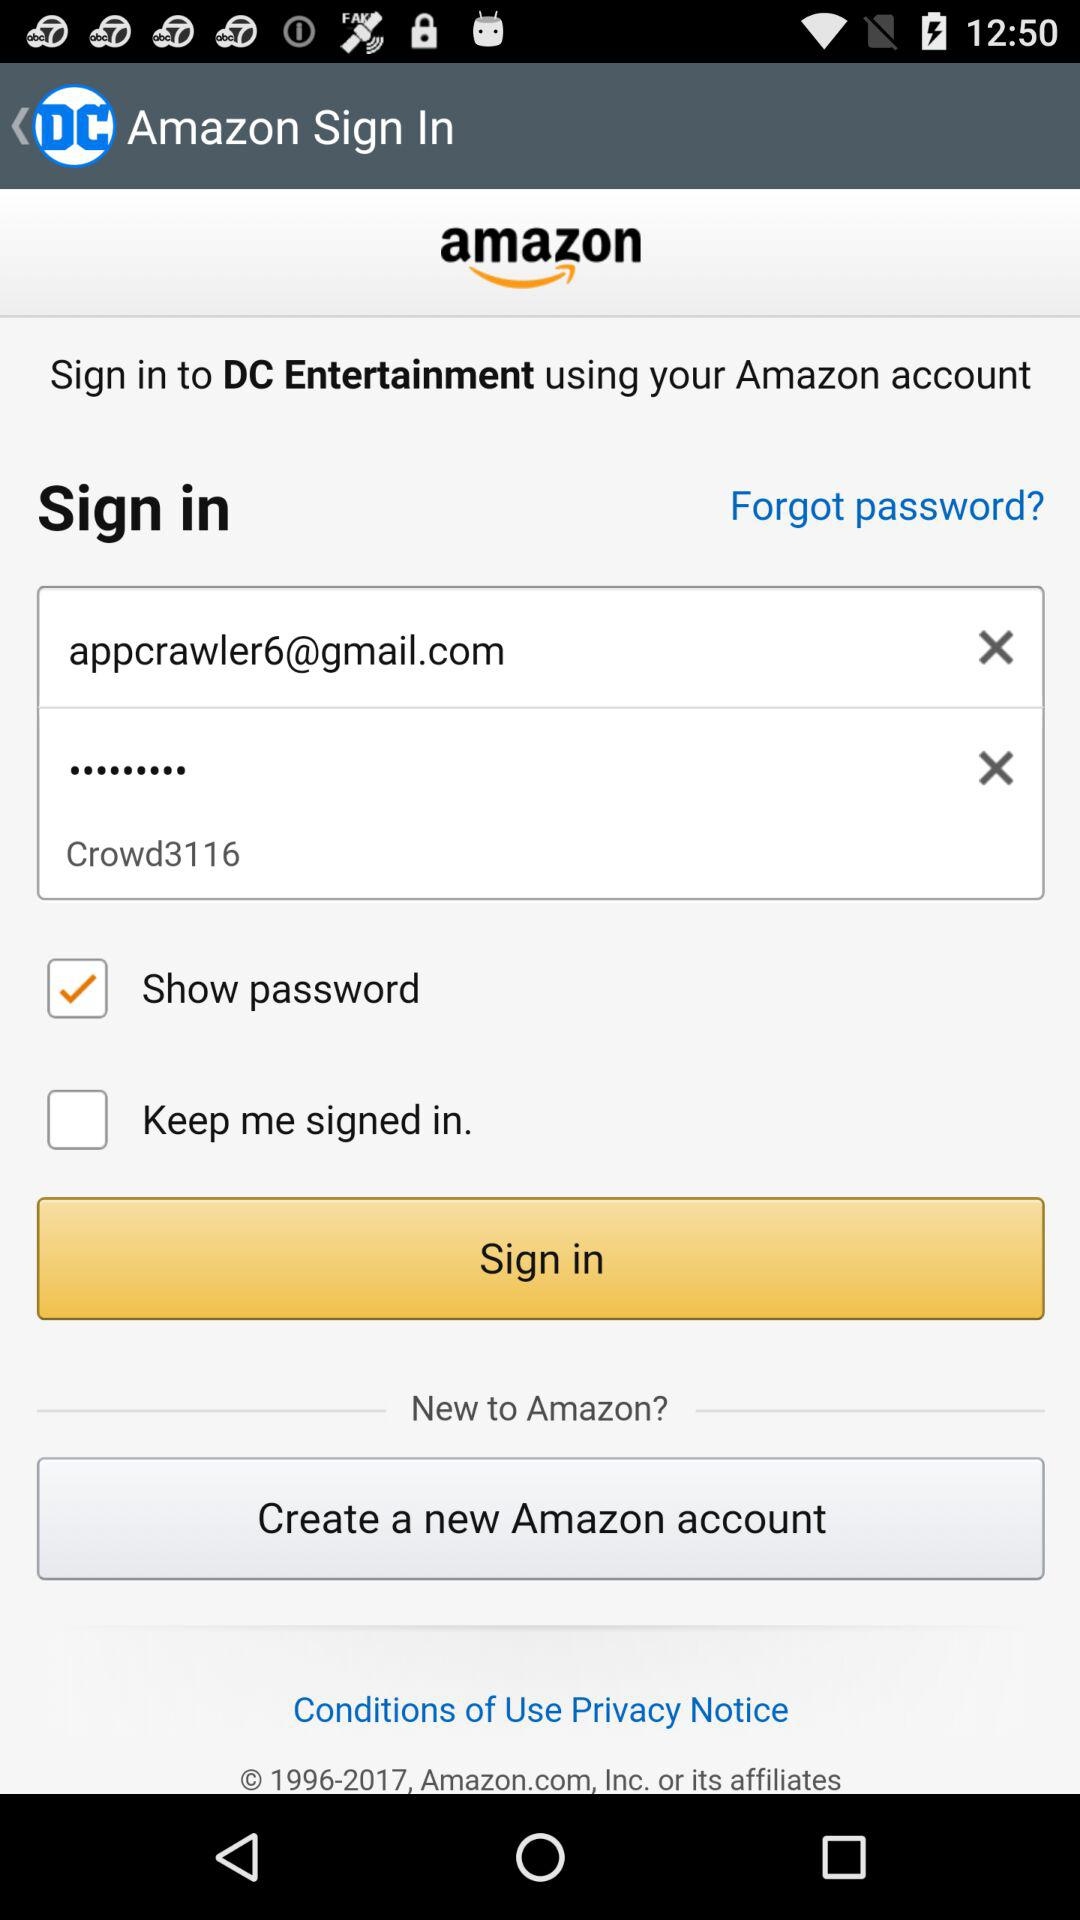What’s the app name? The app name is "amazon". 